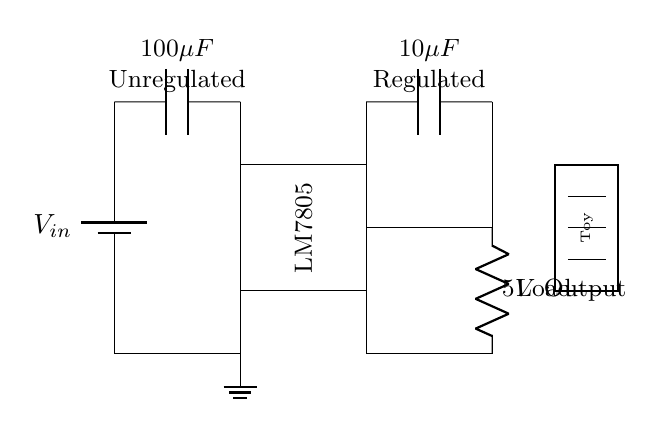What is the input voltage in the circuit? The circuit diagram shows that the input voltage is denoted as V sub in, which typically connects to a battery or other power source. The actual value is not specified but is depicted at the input.
Answer: V sub in What type of voltage regulator is used in the circuit? The circuit clearly labels the voltage regulator as an LM7805, which is a widely known voltage regulator. The identification is present in the rectangle that represents the regulator IC.
Answer: LM7805 What is the output voltage of the circuit? The output is indicated as a five-volt output, which coincides with the designation of the LM7805 regulator, specifying its output voltage.
Answer: 5V Why is there an input capacitor and what is its value? The input capacitor is present at the input of the circuit to stabilize input voltage and reduce noise. Its value is given as 100 microfarads, indicated in the diagram next to the capacitor symbol.
Answer: 100 microfarads What does the output capacitor do in the circuit? The output capacitor in the circuit helps to smooth the output voltage, ensuring a stable power supply to the load, which is a key function in voltage regulator circuits. It is labeled as 10 microfarads in the diagram.
Answer: Stabilizes output What is connected to the output of this regulator? The output of the regulator connects to a load, which is depicted as a rectangle labeled as Toy. This indicates that the power supply is intended for electronic toys.
Answer: Toy What is the purpose of the ground connection in this circuit? The ground connection serves as a common reference point for the circuit and completes the electrical circuit, ensuring proper function and stability of the voltage regulator. It is shown at the bottom of the circuit illustration.
Answer: Common reference 